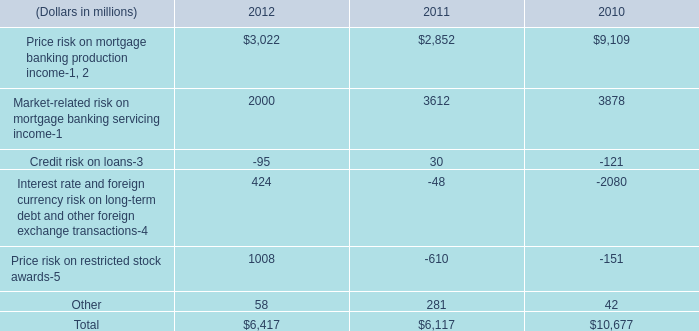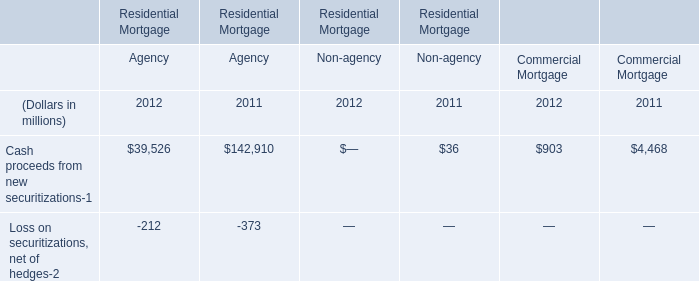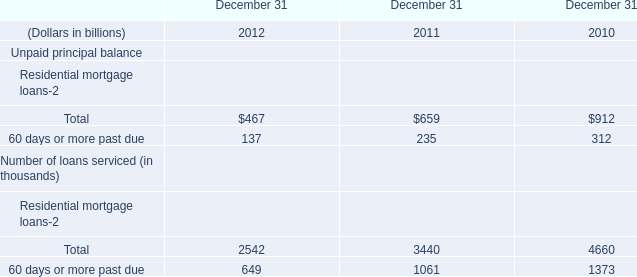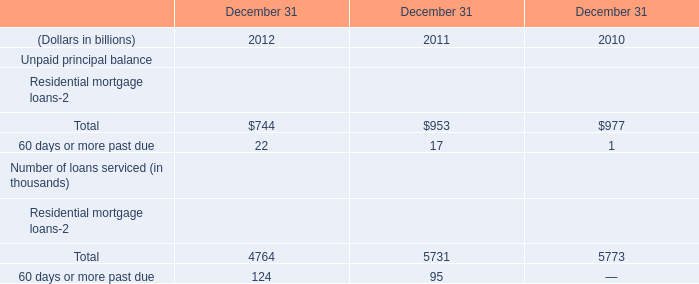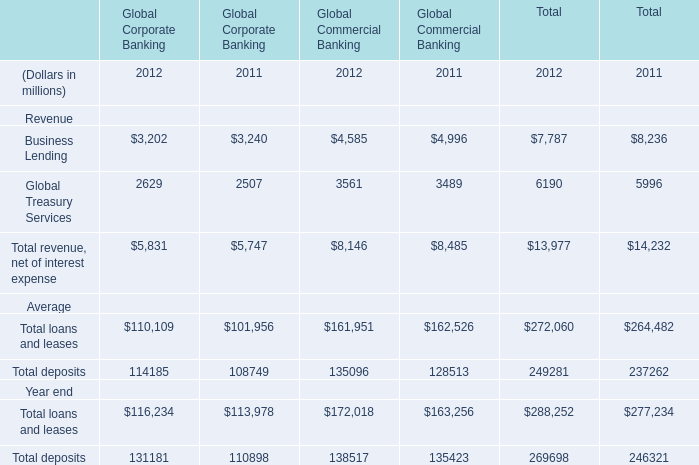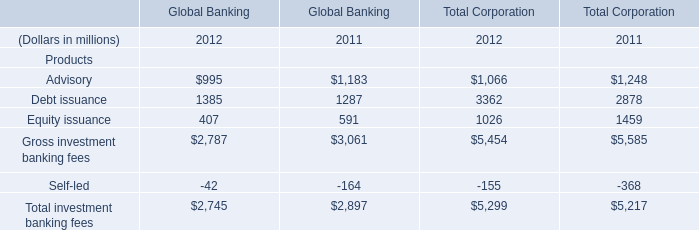What's the average of Business Lending and Global Treasury Services of Global Corporate Banking in 2012? (in millions) 
Computations: ((3202 + 2629) / 2)
Answer: 2915.5. 